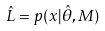<formula> <loc_0><loc_0><loc_500><loc_500>\hat { L } = p ( x | \hat { \theta } , M )</formula> 